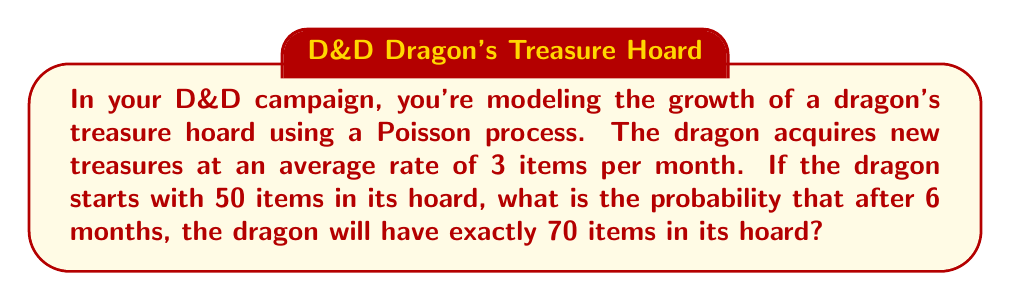Solve this math problem. Let's approach this step-by-step:

1) We're dealing with a Poisson process, where:
   - The rate (λ) is 3 items per month
   - The time period (t) is 6 months
   - The initial number of items is 50
   - The final number of items is 70

2) We need to find the probability of acquiring exactly 20 new items (70 - 50) in 6 months.

3) For a Poisson process, the number of events in a time interval follows a Poisson distribution. The mean of this distribution is λt.

4) In this case, λt = 3 * 6 = 18

5) The probability of exactly k events occurring in a Poisson process is given by the formula:

   $$P(X = k) = \frac{e^{-\lambda t}(\lambda t)^k}{k!}$$

6) Plugging in our values:

   $$P(X = 20) = \frac{e^{-18}(18)^{20}}{20!}$$

7) Calculating this (you may need a calculator):

   $$P(X = 20) \approx 0.0516$$

Therefore, the probability of the dragon having exactly 70 items after 6 months is approximately 0.0516 or 5.16%.
Answer: 0.0516 